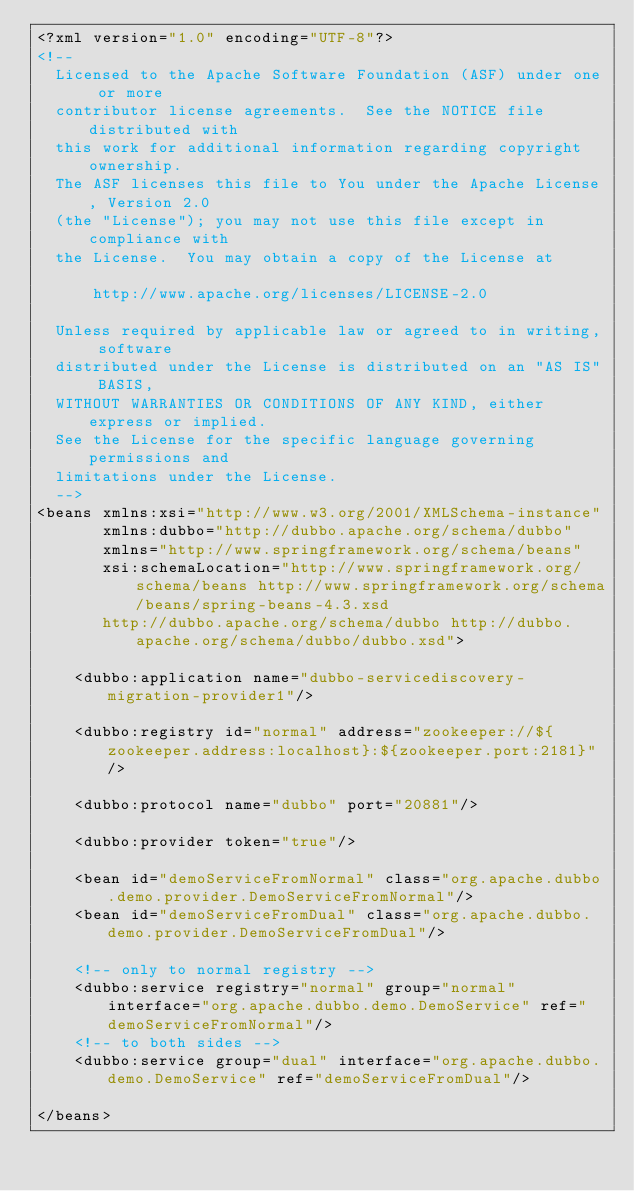<code> <loc_0><loc_0><loc_500><loc_500><_XML_><?xml version="1.0" encoding="UTF-8"?>
<!--
  Licensed to the Apache Software Foundation (ASF) under one or more
  contributor license agreements.  See the NOTICE file distributed with
  this work for additional information regarding copyright ownership.
  The ASF licenses this file to You under the Apache License, Version 2.0
  (the "License"); you may not use this file except in compliance with
  the License.  You may obtain a copy of the License at

      http://www.apache.org/licenses/LICENSE-2.0

  Unless required by applicable law or agreed to in writing, software
  distributed under the License is distributed on an "AS IS" BASIS,
  WITHOUT WARRANTIES OR CONDITIONS OF ANY KIND, either express or implied.
  See the License for the specific language governing permissions and
  limitations under the License.
  -->
<beans xmlns:xsi="http://www.w3.org/2001/XMLSchema-instance"
       xmlns:dubbo="http://dubbo.apache.org/schema/dubbo"
       xmlns="http://www.springframework.org/schema/beans"
       xsi:schemaLocation="http://www.springframework.org/schema/beans http://www.springframework.org/schema/beans/spring-beans-4.3.xsd
       http://dubbo.apache.org/schema/dubbo http://dubbo.apache.org/schema/dubbo/dubbo.xsd">

    <dubbo:application name="dubbo-servicediscovery-migration-provider1"/>

    <dubbo:registry id="normal" address="zookeeper://${zookeeper.address:localhost}:${zookeeper.port:2181}"/>

    <dubbo:protocol name="dubbo" port="20881"/>

    <dubbo:provider token="true"/>

    <bean id="demoServiceFromNormal" class="org.apache.dubbo.demo.provider.DemoServiceFromNormal"/>
    <bean id="demoServiceFromDual" class="org.apache.dubbo.demo.provider.DemoServiceFromDual"/>

    <!-- only to normal registry -->
    <dubbo:service registry="normal" group="normal" interface="org.apache.dubbo.demo.DemoService" ref="demoServiceFromNormal"/>
    <!-- to both sides -->
    <dubbo:service group="dual" interface="org.apache.dubbo.demo.DemoService" ref="demoServiceFromDual"/>

</beans>
</code> 